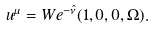<formula> <loc_0><loc_0><loc_500><loc_500>u ^ { \mu } = W e ^ { - \hat { \nu } } ( 1 , 0 , 0 , \Omega ) .</formula> 